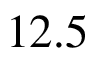Convert formula to latex. <formula><loc_0><loc_0><loc_500><loc_500>1 2 . 5</formula> 